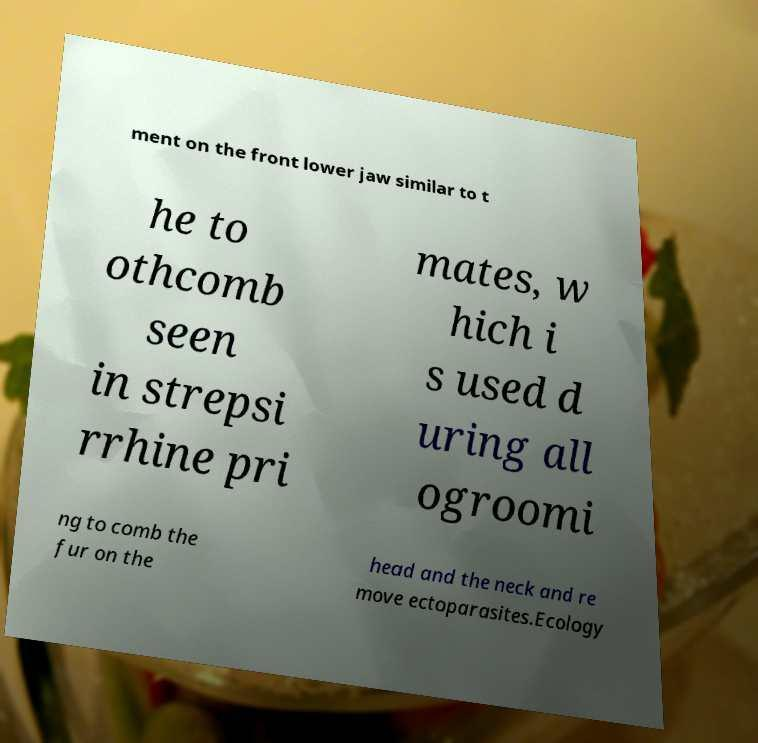Please identify and transcribe the text found in this image. ment on the front lower jaw similar to t he to othcomb seen in strepsi rrhine pri mates, w hich i s used d uring all ogroomi ng to comb the fur on the head and the neck and re move ectoparasites.Ecology 